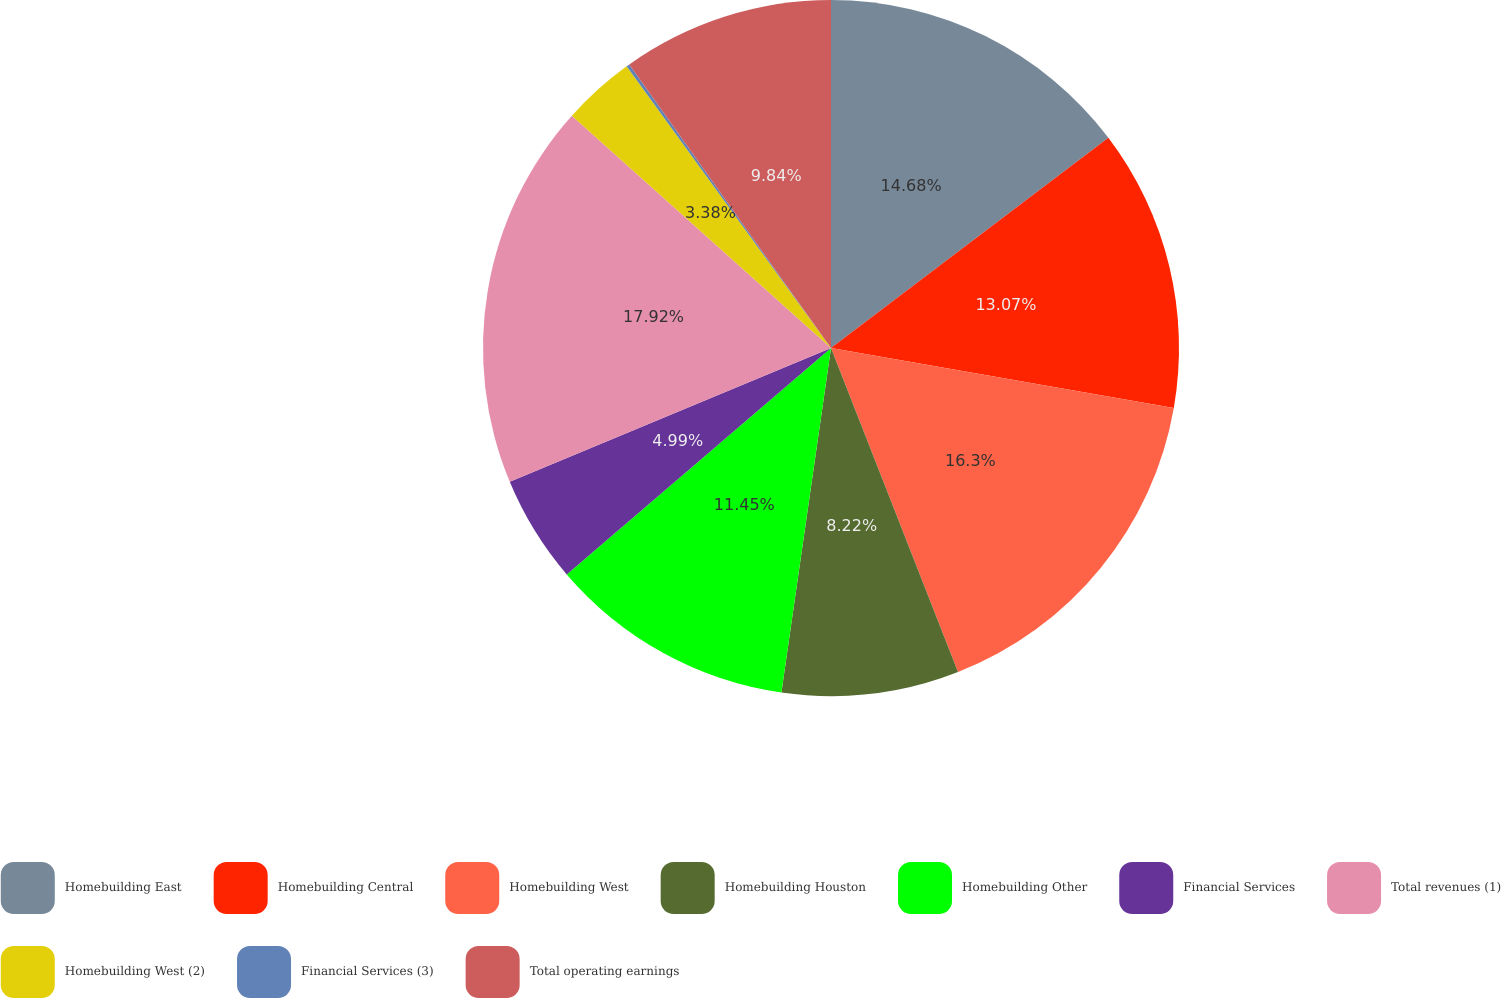Convert chart. <chart><loc_0><loc_0><loc_500><loc_500><pie_chart><fcel>Homebuilding East<fcel>Homebuilding Central<fcel>Homebuilding West<fcel>Homebuilding Houston<fcel>Homebuilding Other<fcel>Financial Services<fcel>Total revenues (1)<fcel>Homebuilding West (2)<fcel>Financial Services (3)<fcel>Total operating earnings<nl><fcel>14.68%<fcel>13.07%<fcel>16.3%<fcel>8.22%<fcel>11.45%<fcel>4.99%<fcel>17.91%<fcel>3.38%<fcel>0.15%<fcel>9.84%<nl></chart> 